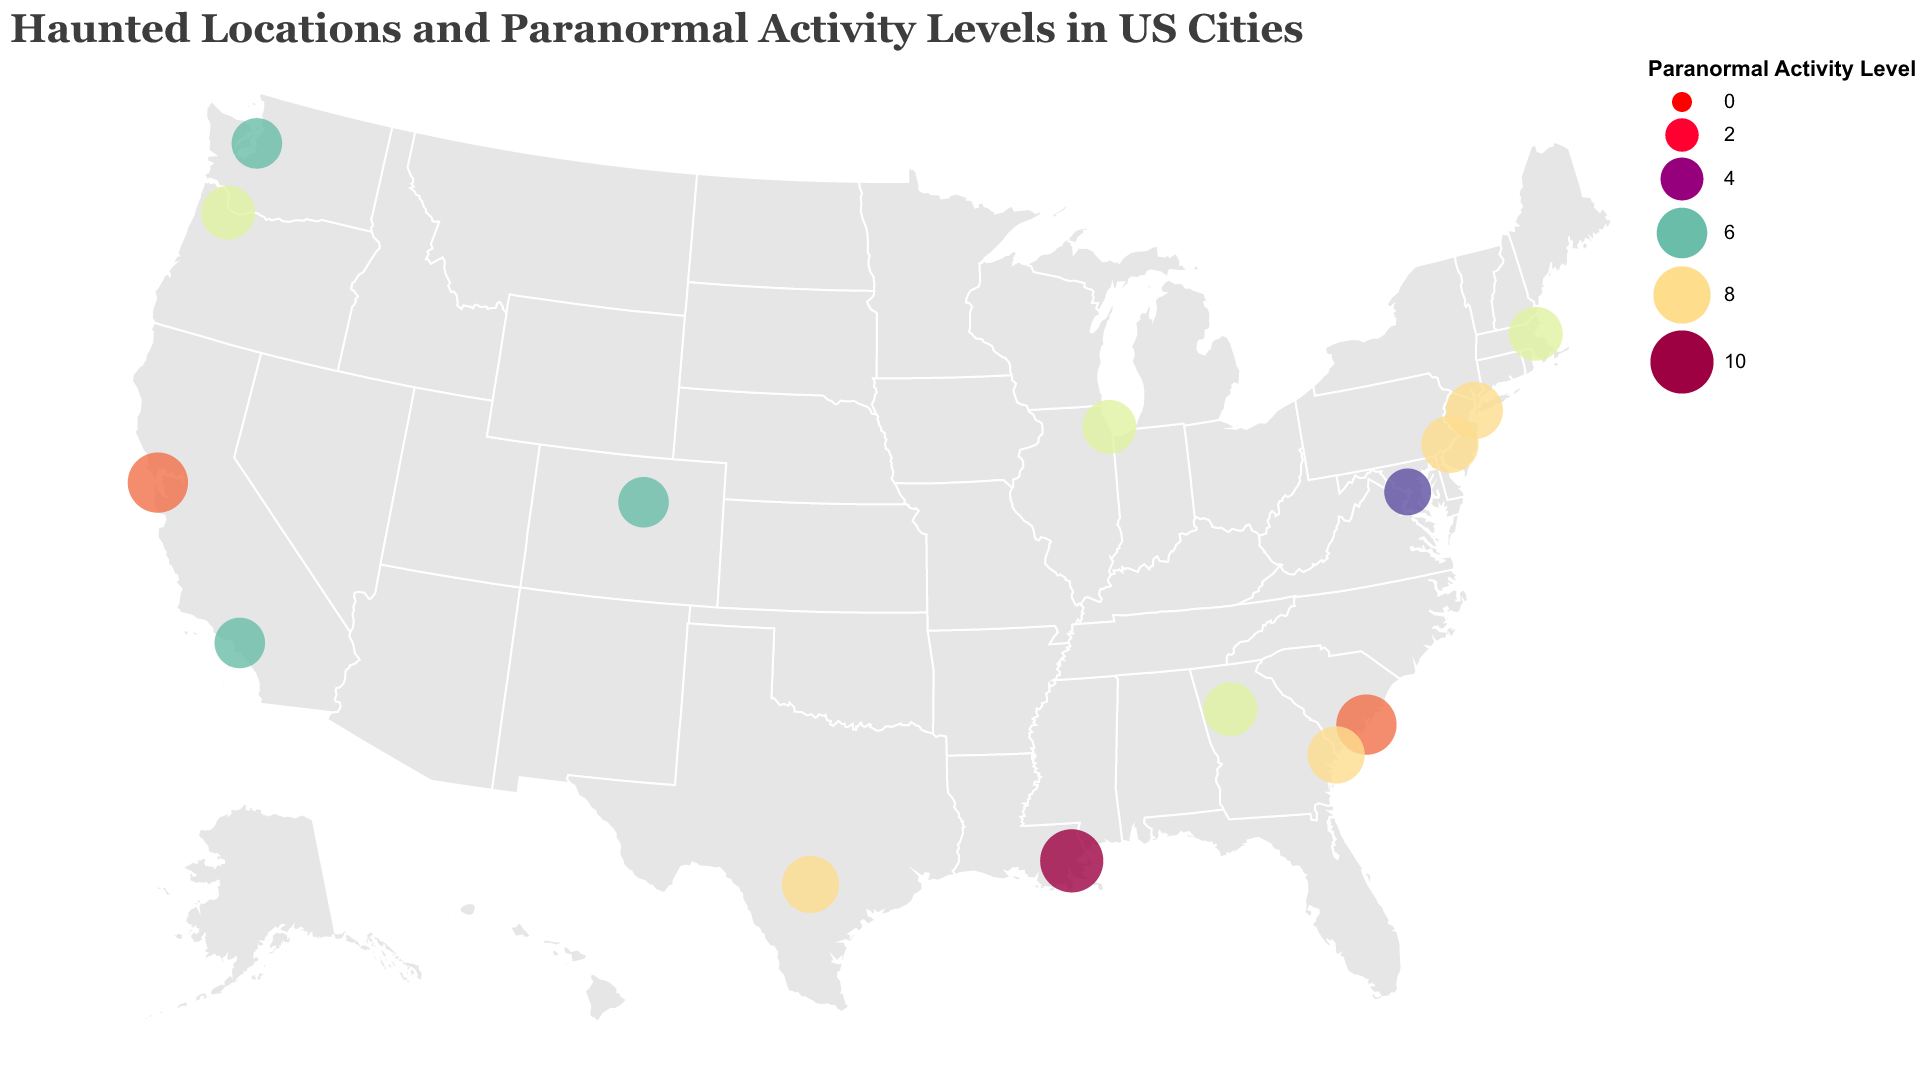What city has the highest level of reported paranormal activity? New Orleans has the highest reported paranormal activity level at the Lalaurie Mansion with a level of 10.
Answer: New Orleans Which location in New York City is marked as haunted, and what is its paranormal activity level? The figure indicates that The Dakota in New York City has a paranormal activity level of 8.
Answer: The Dakota, level 8 Between Philadelphia and Charleston, which city has a higher paranormal activity level at their haunted locations? Charleston's Old City Jail has a paranormal activity level of 9, while Philadelphia's Eastern State Penitentiary has a level of 8. Therefore, Charleston has a higher activity level.
Answer: Charleston What is the total reported paranormal activity level for the cities on the West Coast (Los Angeles, San Francisco, Seattle, Portland)? Summing the paranormal activity levels: Los Angeles (6) + San Francisco (9) + Seattle (6) + Portland (7) = 28.
Answer: 28 How many cities have a paranormal activity level of 7? The figure shows cities with a paranormal activity level of 7 are Chicago, Boston, Atlanta, and Portland, totaling 4 cities.
Answer: 4 Is the paranormal activity level at Alcatraz Island higher than at The White House? The figure indicates that the paranormal activity level is higher at Alcatraz Island (9) compared to The White House (5).
Answer: Yes What is the average paranormal activity level of all the haunted locations listed? Summing the paranormal activity levels (8+7+6+9+10+7+8+5+6+7+6+8+7+9+8) gives 105. Dividing by the number of locations (15), the average is 105/15 = 7.
Answer: 7 Which city in Georgia has a location with a reported paranormal activity level, and what is the level? The cities in Georgia listed are Atlanta, with Oakland Cemetery having a level of 7, and Savannah, with Bonaventure Cemetery having a level of 8.
Answer: Atlanta, level 7 and Savannah, level 8 